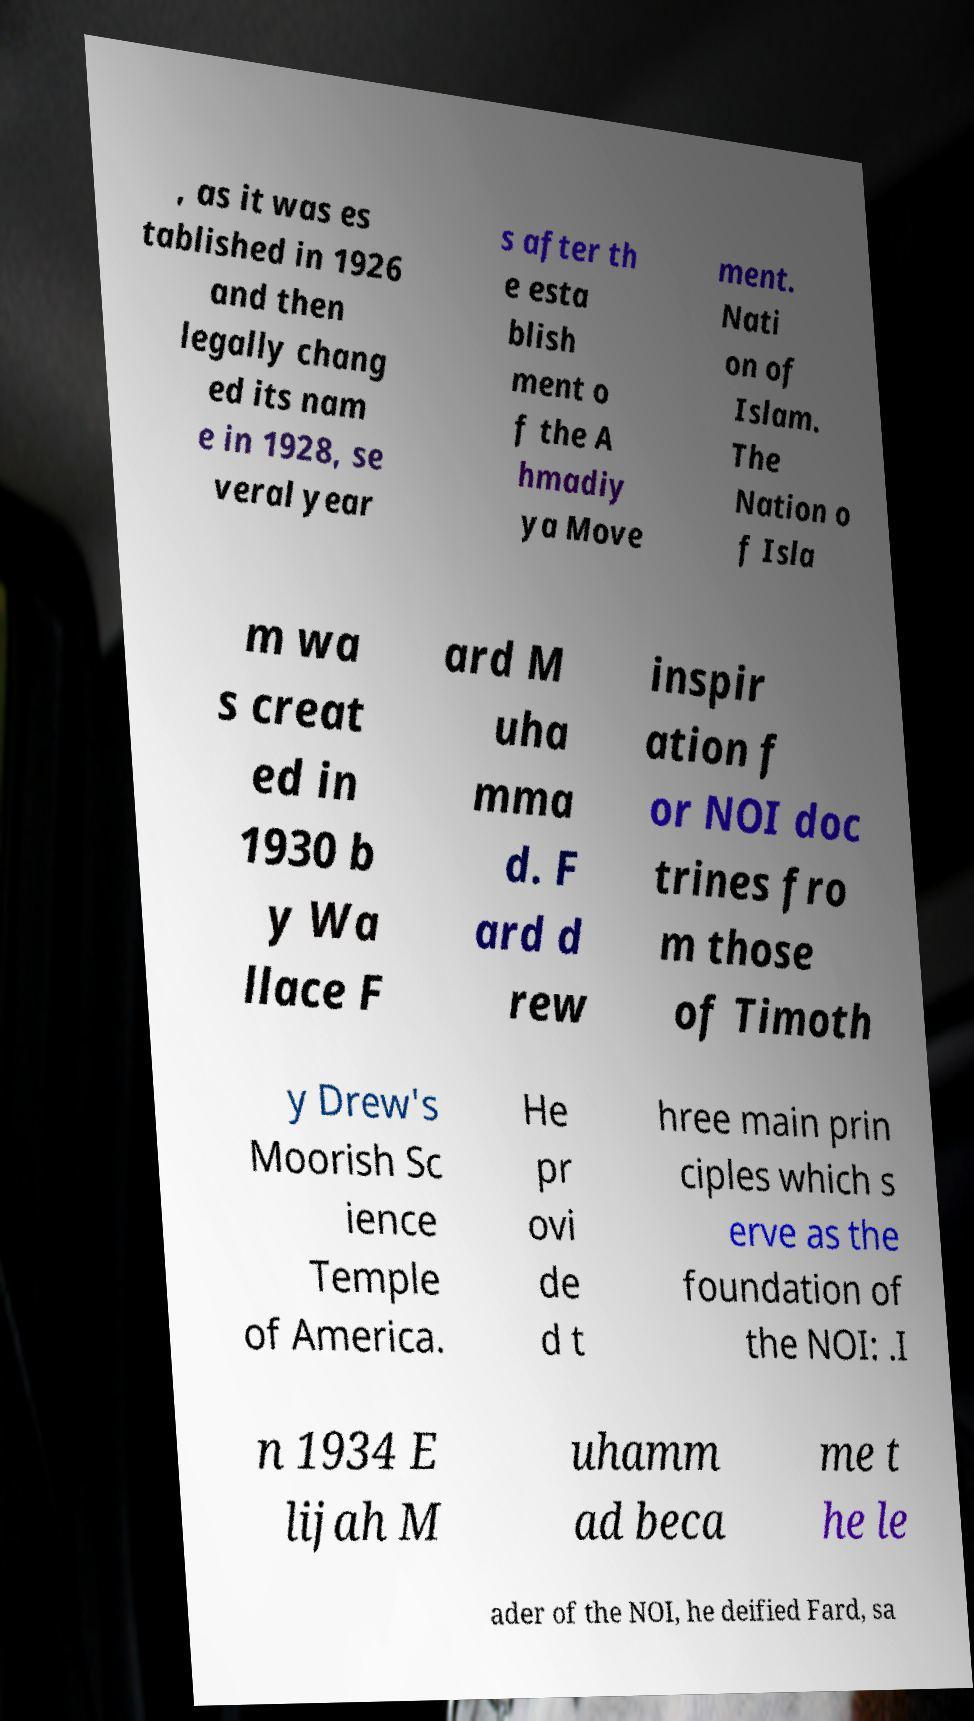Can you read and provide the text displayed in the image?This photo seems to have some interesting text. Can you extract and type it out for me? , as it was es tablished in 1926 and then legally chang ed its nam e in 1928, se veral year s after th e esta blish ment o f the A hmadiy ya Move ment. Nati on of Islam. The Nation o f Isla m wa s creat ed in 1930 b y Wa llace F ard M uha mma d. F ard d rew inspir ation f or NOI doc trines fro m those of Timoth y Drew's Moorish Sc ience Temple of America. He pr ovi de d t hree main prin ciples which s erve as the foundation of the NOI: .I n 1934 E lijah M uhamm ad beca me t he le ader of the NOI, he deified Fard, sa 